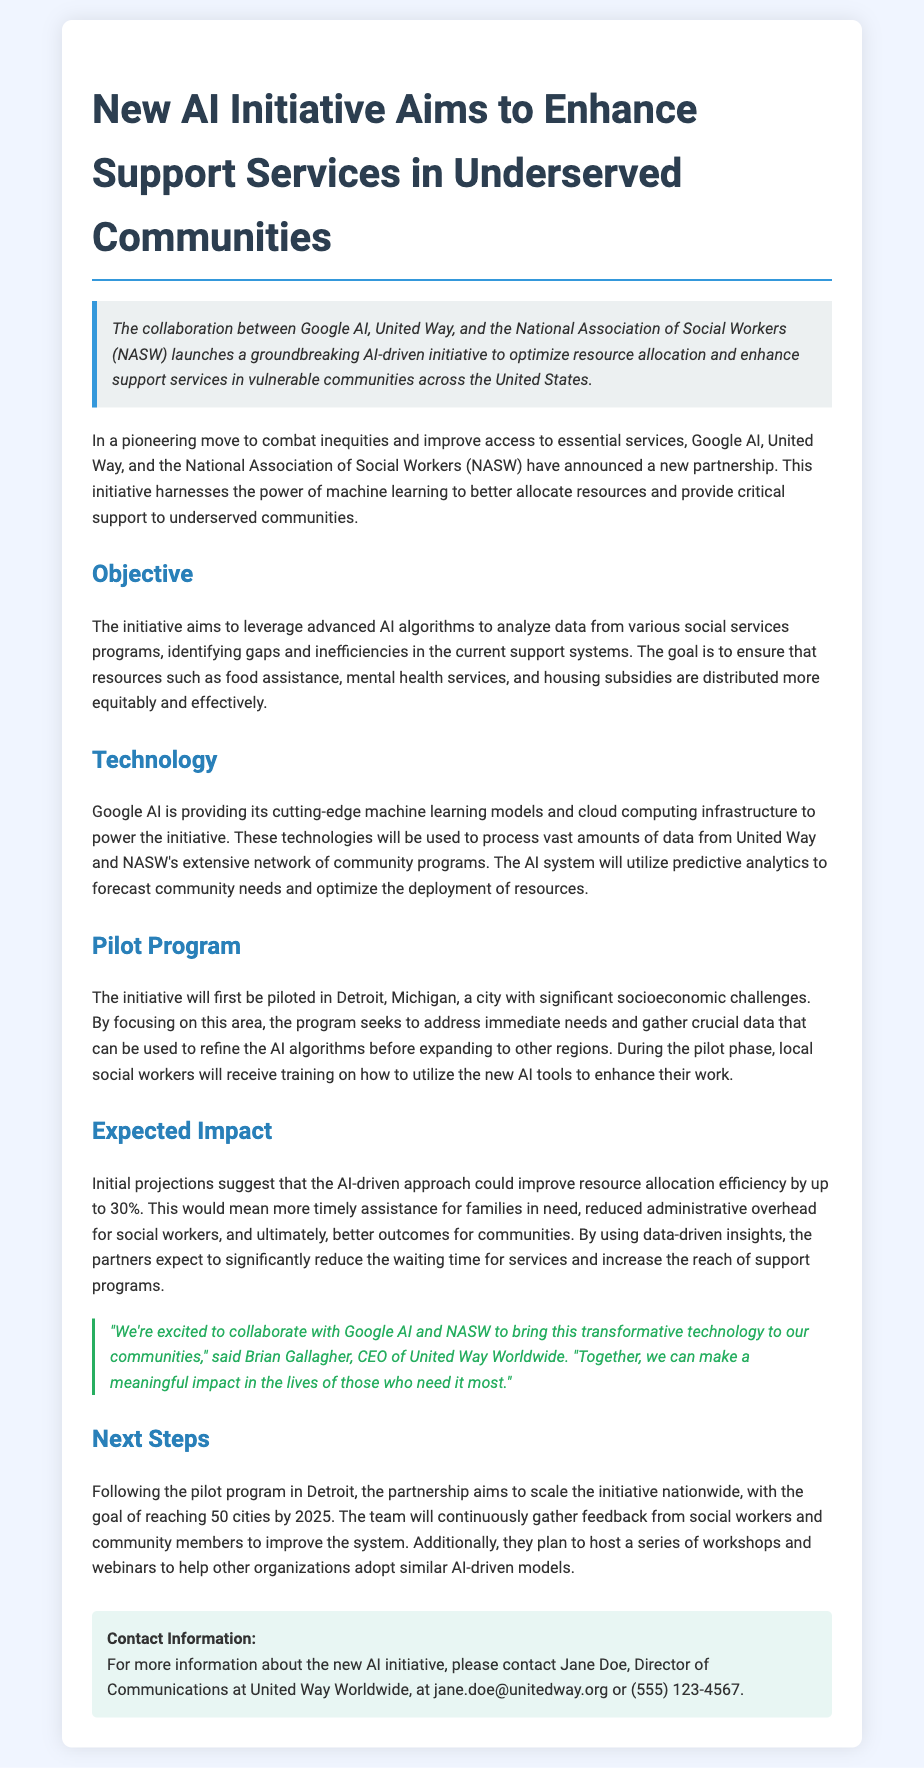What organizations are collaborating on the initiative? The document states that Google AI, United Way, and the National Association of Social Workers (NASW) are collaborating on the initiative.
Answer: Google AI, United Way, NASW What is the primary goal of the initiative? The document mentions that the goal is to optimize resource allocation and enhance support services in vulnerable communities.
Answer: Optimize resource allocation What city will the pilot program first be implemented in? The document specifies that the pilot program will first be piloted in Detroit, Michigan.
Answer: Detroit, Michigan By what percentage is the initiative expected to improve resource allocation efficiency? The document states that initial projections suggest an improvement of resource allocation efficiency by up to 30%.
Answer: 30% Who is the CEO of United Way Worldwide mentioned in the document? The document quotes Brian Gallagher as the CEO of United Way Worldwide.
Answer: Brian Gallagher What technology does Google AI provide for this initiative? The document mentions that Google AI is providing machine learning models and cloud computing infrastructure.
Answer: Machine learning models, cloud computing infrastructure What is the expected completion date for reaching 50 cities with the initiative? The document indicates that the partnership aims to reach 50 cities by 2025.
Answer: 2025 What type of training will local social workers receive during the pilot phase? According to the document, local social workers will receive training on how to utilize the new AI tools.
Answer: Training on new AI tools What specific areas of assistance does the initiative aim to improve? The document lists food assistance, mental health services, and housing subsidies as areas to be improved.
Answer: Food assistance, mental health services, housing subsidies 